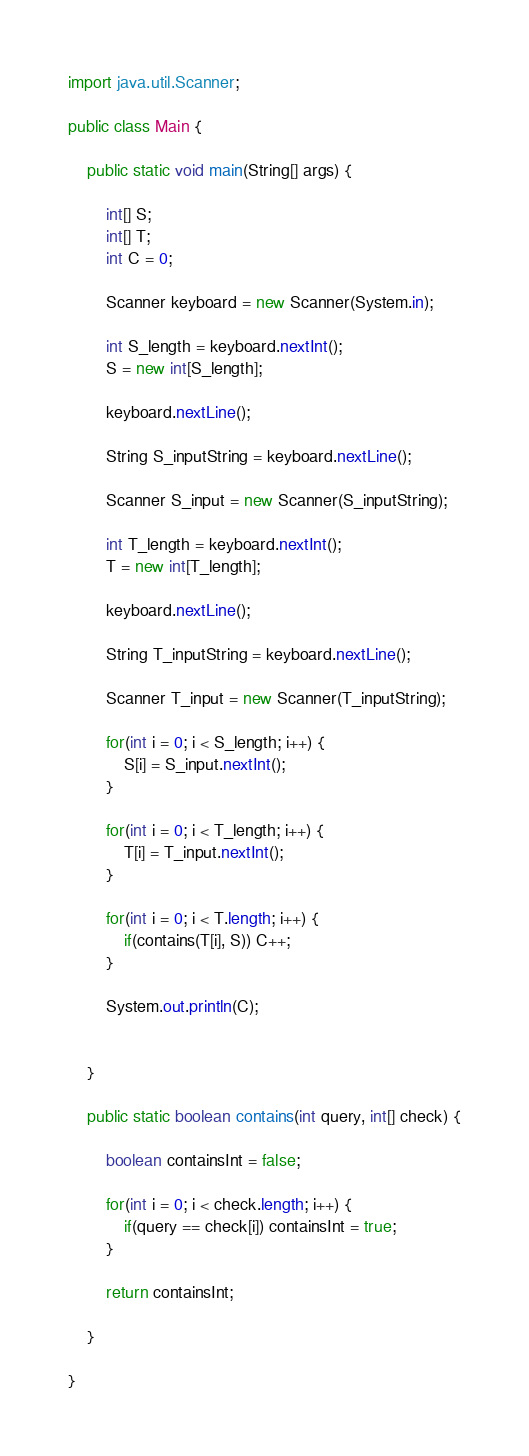<code> <loc_0><loc_0><loc_500><loc_500><_Java_>import java.util.Scanner;

public class Main {
	
	public static void main(String[] args) {
		
		int[] S;
		int[] T;
		int C = 0;
		
		Scanner keyboard = new Scanner(System.in);
		
		int S_length = keyboard.nextInt();
		S = new int[S_length];
		
		keyboard.nextLine();
		
		String S_inputString = keyboard.nextLine();
		
		Scanner S_input = new Scanner(S_inputString);
		
		int T_length = keyboard.nextInt();
		T = new int[T_length];
		
		keyboard.nextLine();
		
		String T_inputString = keyboard.nextLine();
		
		Scanner T_input = new Scanner(T_inputString);
		
		for(int i = 0; i < S_length; i++) {
			S[i] = S_input.nextInt();
		}
		
		for(int i = 0; i < T_length; i++) {
			T[i] = T_input.nextInt();
		}
		
		for(int i = 0; i < T.length; i++) {
			if(contains(T[i], S)) C++;
		}
		
		System.out.println(C);
		
		
	}
	
	public static boolean contains(int query, int[] check) {
		
		boolean containsInt = false;
		
		for(int i = 0; i < check.length; i++) {
			if(query == check[i]) containsInt = true;
		}
		
		return containsInt;
		
	}

}
</code> 